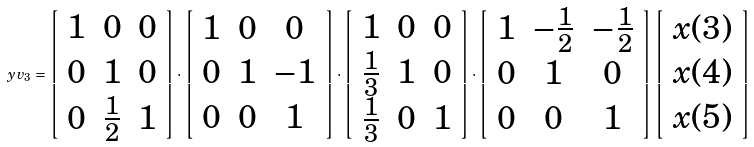<formula> <loc_0><loc_0><loc_500><loc_500>\ y v _ { 3 } = \left [ \begin{array} { c c c } 1 & 0 & 0 \\ 0 & 1 & 0 \\ 0 & \frac { 1 } { 2 } & 1 \end{array} \right ] \cdot \left [ \begin{array} { c c c } 1 & 0 & 0 \\ 0 & 1 & - 1 \\ 0 & 0 & 1 \end{array} \right ] \cdot \left [ \begin{array} { c c c } 1 & 0 & 0 \\ \frac { 1 } { 3 } & 1 & 0 \\ \frac { 1 } { 3 } & 0 & 1 \end{array} \right ] \cdot \left [ \begin{array} { c c c } 1 & - \frac { 1 } { 2 } & - \frac { 1 } { 2 } \\ 0 & 1 & 0 \\ 0 & 0 & 1 \end{array} \right ] \left [ \begin{array} { c } x ( 3 ) \\ x ( 4 ) \\ x ( 5 ) \end{array} \right ]</formula> 